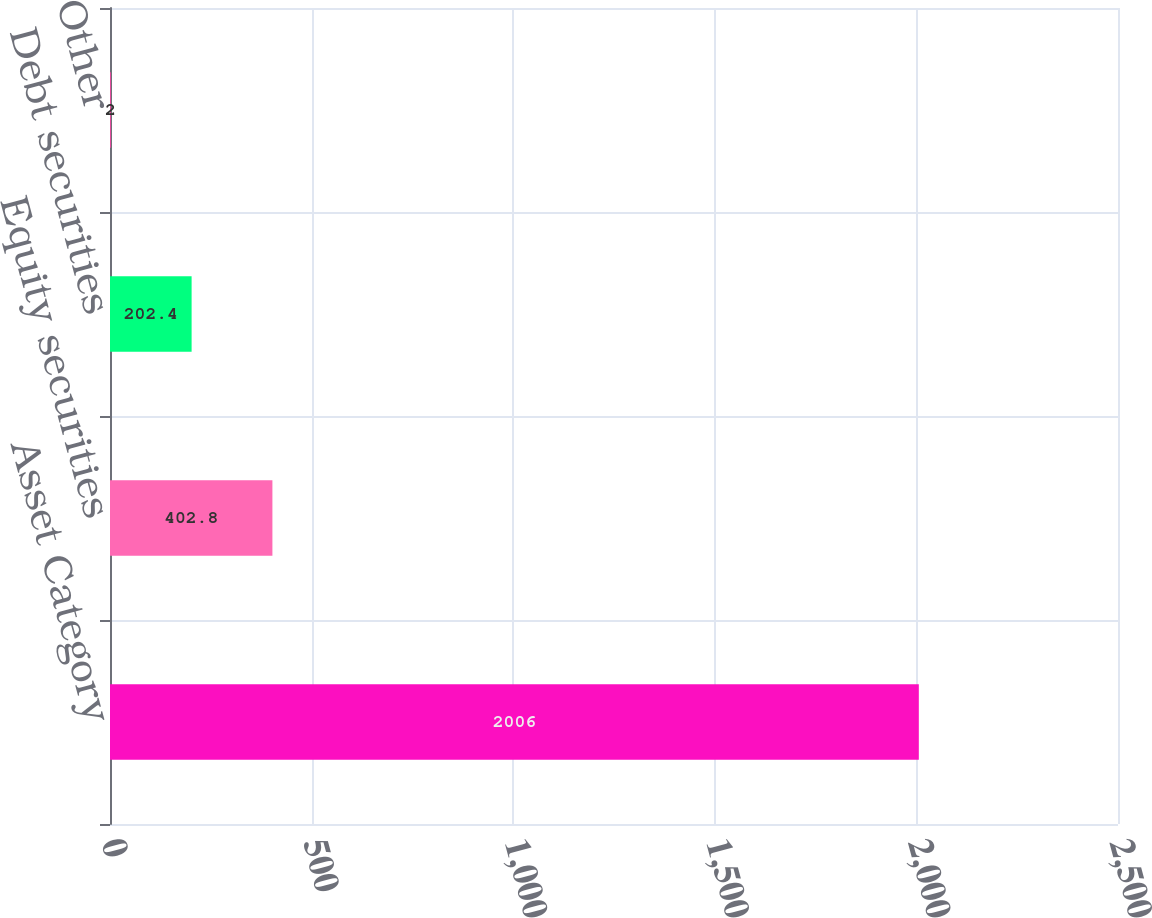<chart> <loc_0><loc_0><loc_500><loc_500><bar_chart><fcel>Asset Category<fcel>Equity securities<fcel>Debt securities<fcel>Other<nl><fcel>2006<fcel>402.8<fcel>202.4<fcel>2<nl></chart> 